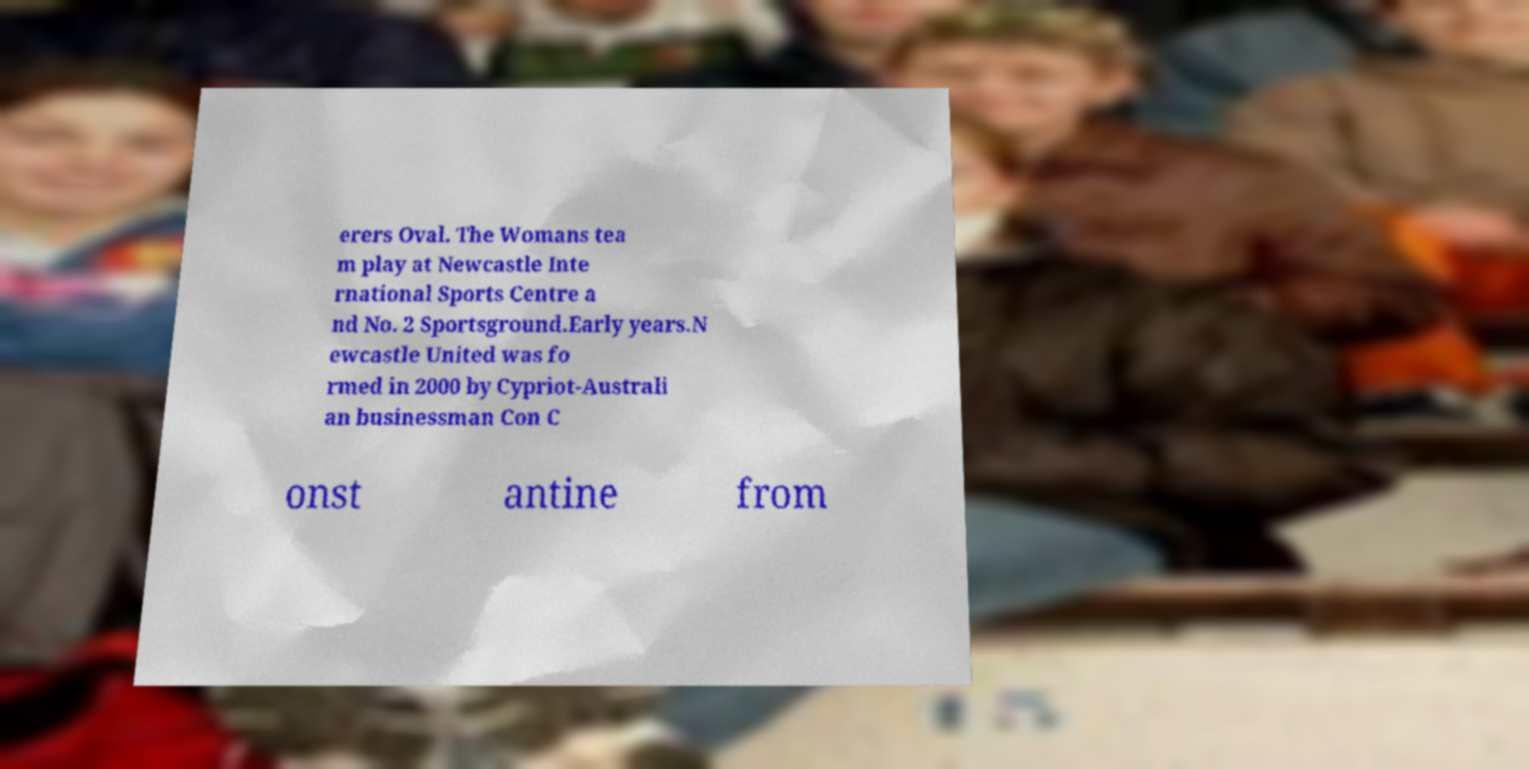Can you read and provide the text displayed in the image?This photo seems to have some interesting text. Can you extract and type it out for me? erers Oval. The Womans tea m play at Newcastle Inte rnational Sports Centre a nd No. 2 Sportsground.Early years.N ewcastle United was fo rmed in 2000 by Cypriot-Australi an businessman Con C onst antine from 